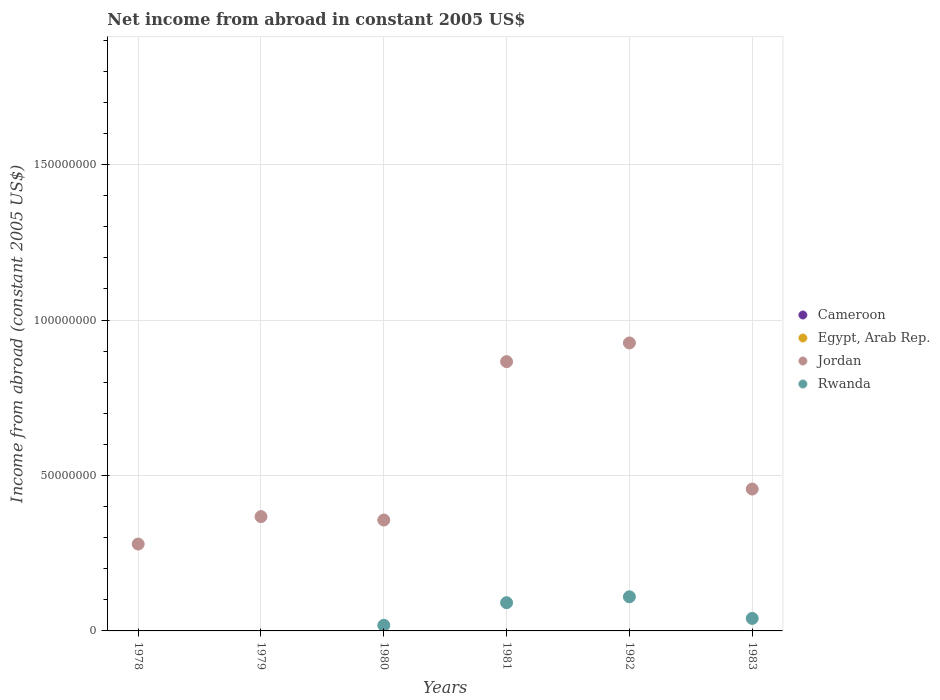How many different coloured dotlines are there?
Your answer should be compact. 2. Is the number of dotlines equal to the number of legend labels?
Your answer should be very brief. No. What is the net income from abroad in Jordan in 1978?
Your response must be concise. 2.79e+07. Across all years, what is the maximum net income from abroad in Rwanda?
Offer a very short reply. 1.10e+07. Across all years, what is the minimum net income from abroad in Cameroon?
Offer a terse response. 0. In which year was the net income from abroad in Rwanda maximum?
Make the answer very short. 1982. What is the total net income from abroad in Rwanda in the graph?
Offer a terse response. 2.59e+07. What is the difference between the net income from abroad in Jordan in 1978 and that in 1980?
Provide a short and direct response. -7.72e+06. What is the difference between the net income from abroad in Rwanda in 1979 and the net income from abroad in Jordan in 1981?
Ensure brevity in your answer.  -8.66e+07. In the year 1980, what is the difference between the net income from abroad in Jordan and net income from abroad in Rwanda?
Give a very brief answer. 3.39e+07. In how many years, is the net income from abroad in Cameroon greater than 160000000 US$?
Your response must be concise. 0. What is the ratio of the net income from abroad in Rwanda in 1980 to that in 1981?
Your answer should be compact. 0.2. What is the difference between the highest and the second highest net income from abroad in Rwanda?
Provide a succinct answer. 1.90e+06. What is the difference between the highest and the lowest net income from abroad in Rwanda?
Keep it short and to the point. 1.10e+07. Is the sum of the net income from abroad in Jordan in 1980 and 1982 greater than the maximum net income from abroad in Egypt, Arab Rep. across all years?
Your response must be concise. Yes. Is it the case that in every year, the sum of the net income from abroad in Rwanda and net income from abroad in Egypt, Arab Rep.  is greater than the net income from abroad in Jordan?
Offer a terse response. No. How many dotlines are there?
Keep it short and to the point. 2. How many years are there in the graph?
Offer a terse response. 6. What is the difference between two consecutive major ticks on the Y-axis?
Keep it short and to the point. 5.00e+07. Are the values on the major ticks of Y-axis written in scientific E-notation?
Give a very brief answer. No. Does the graph contain any zero values?
Make the answer very short. Yes. How many legend labels are there?
Offer a terse response. 4. How are the legend labels stacked?
Make the answer very short. Vertical. What is the title of the graph?
Make the answer very short. Net income from abroad in constant 2005 US$. What is the label or title of the X-axis?
Your response must be concise. Years. What is the label or title of the Y-axis?
Provide a short and direct response. Income from abroad (constant 2005 US$). What is the Income from abroad (constant 2005 US$) in Cameroon in 1978?
Provide a short and direct response. 0. What is the Income from abroad (constant 2005 US$) of Jordan in 1978?
Keep it short and to the point. 2.79e+07. What is the Income from abroad (constant 2005 US$) in Cameroon in 1979?
Keep it short and to the point. 0. What is the Income from abroad (constant 2005 US$) in Egypt, Arab Rep. in 1979?
Ensure brevity in your answer.  0. What is the Income from abroad (constant 2005 US$) in Jordan in 1979?
Give a very brief answer. 3.68e+07. What is the Income from abroad (constant 2005 US$) in Rwanda in 1979?
Provide a succinct answer. 0. What is the Income from abroad (constant 2005 US$) of Jordan in 1980?
Keep it short and to the point. 3.57e+07. What is the Income from abroad (constant 2005 US$) of Rwanda in 1980?
Provide a short and direct response. 1.80e+06. What is the Income from abroad (constant 2005 US$) in Jordan in 1981?
Offer a very short reply. 8.66e+07. What is the Income from abroad (constant 2005 US$) in Rwanda in 1981?
Make the answer very short. 9.08e+06. What is the Income from abroad (constant 2005 US$) of Egypt, Arab Rep. in 1982?
Provide a succinct answer. 0. What is the Income from abroad (constant 2005 US$) of Jordan in 1982?
Offer a terse response. 9.26e+07. What is the Income from abroad (constant 2005 US$) of Rwanda in 1982?
Offer a very short reply. 1.10e+07. What is the Income from abroad (constant 2005 US$) in Egypt, Arab Rep. in 1983?
Offer a very short reply. 0. What is the Income from abroad (constant 2005 US$) of Jordan in 1983?
Your answer should be compact. 4.56e+07. What is the Income from abroad (constant 2005 US$) in Rwanda in 1983?
Your answer should be very brief. 4.03e+06. Across all years, what is the maximum Income from abroad (constant 2005 US$) in Jordan?
Your answer should be very brief. 9.26e+07. Across all years, what is the maximum Income from abroad (constant 2005 US$) of Rwanda?
Your answer should be compact. 1.10e+07. Across all years, what is the minimum Income from abroad (constant 2005 US$) of Jordan?
Keep it short and to the point. 2.79e+07. What is the total Income from abroad (constant 2005 US$) of Egypt, Arab Rep. in the graph?
Keep it short and to the point. 0. What is the total Income from abroad (constant 2005 US$) in Jordan in the graph?
Your answer should be very brief. 3.25e+08. What is the total Income from abroad (constant 2005 US$) of Rwanda in the graph?
Your answer should be compact. 2.59e+07. What is the difference between the Income from abroad (constant 2005 US$) of Jordan in 1978 and that in 1979?
Give a very brief answer. -8.82e+06. What is the difference between the Income from abroad (constant 2005 US$) of Jordan in 1978 and that in 1980?
Keep it short and to the point. -7.72e+06. What is the difference between the Income from abroad (constant 2005 US$) in Jordan in 1978 and that in 1981?
Offer a very short reply. -5.87e+07. What is the difference between the Income from abroad (constant 2005 US$) in Jordan in 1978 and that in 1982?
Provide a succinct answer. -6.47e+07. What is the difference between the Income from abroad (constant 2005 US$) of Jordan in 1978 and that in 1983?
Provide a succinct answer. -1.77e+07. What is the difference between the Income from abroad (constant 2005 US$) of Jordan in 1979 and that in 1980?
Your answer should be compact. 1.10e+06. What is the difference between the Income from abroad (constant 2005 US$) in Jordan in 1979 and that in 1981?
Provide a succinct answer. -4.98e+07. What is the difference between the Income from abroad (constant 2005 US$) in Jordan in 1979 and that in 1982?
Your response must be concise. -5.59e+07. What is the difference between the Income from abroad (constant 2005 US$) in Jordan in 1979 and that in 1983?
Ensure brevity in your answer.  -8.87e+06. What is the difference between the Income from abroad (constant 2005 US$) of Jordan in 1980 and that in 1981?
Ensure brevity in your answer.  -5.09e+07. What is the difference between the Income from abroad (constant 2005 US$) in Rwanda in 1980 and that in 1981?
Ensure brevity in your answer.  -7.27e+06. What is the difference between the Income from abroad (constant 2005 US$) of Jordan in 1980 and that in 1982?
Your answer should be very brief. -5.70e+07. What is the difference between the Income from abroad (constant 2005 US$) of Rwanda in 1980 and that in 1982?
Your response must be concise. -9.17e+06. What is the difference between the Income from abroad (constant 2005 US$) in Jordan in 1980 and that in 1983?
Provide a short and direct response. -9.97e+06. What is the difference between the Income from abroad (constant 2005 US$) in Rwanda in 1980 and that in 1983?
Provide a succinct answer. -2.22e+06. What is the difference between the Income from abroad (constant 2005 US$) in Jordan in 1981 and that in 1982?
Offer a terse response. -6.02e+06. What is the difference between the Income from abroad (constant 2005 US$) in Rwanda in 1981 and that in 1982?
Ensure brevity in your answer.  -1.90e+06. What is the difference between the Income from abroad (constant 2005 US$) of Jordan in 1981 and that in 1983?
Your answer should be compact. 4.10e+07. What is the difference between the Income from abroad (constant 2005 US$) in Rwanda in 1981 and that in 1983?
Give a very brief answer. 5.05e+06. What is the difference between the Income from abroad (constant 2005 US$) of Jordan in 1982 and that in 1983?
Offer a terse response. 4.70e+07. What is the difference between the Income from abroad (constant 2005 US$) in Rwanda in 1982 and that in 1983?
Your answer should be very brief. 6.95e+06. What is the difference between the Income from abroad (constant 2005 US$) of Jordan in 1978 and the Income from abroad (constant 2005 US$) of Rwanda in 1980?
Your answer should be very brief. 2.61e+07. What is the difference between the Income from abroad (constant 2005 US$) in Jordan in 1978 and the Income from abroad (constant 2005 US$) in Rwanda in 1981?
Your answer should be very brief. 1.89e+07. What is the difference between the Income from abroad (constant 2005 US$) of Jordan in 1978 and the Income from abroad (constant 2005 US$) of Rwanda in 1982?
Offer a very short reply. 1.70e+07. What is the difference between the Income from abroad (constant 2005 US$) in Jordan in 1978 and the Income from abroad (constant 2005 US$) in Rwanda in 1983?
Provide a succinct answer. 2.39e+07. What is the difference between the Income from abroad (constant 2005 US$) in Jordan in 1979 and the Income from abroad (constant 2005 US$) in Rwanda in 1980?
Keep it short and to the point. 3.50e+07. What is the difference between the Income from abroad (constant 2005 US$) in Jordan in 1979 and the Income from abroad (constant 2005 US$) in Rwanda in 1981?
Provide a short and direct response. 2.77e+07. What is the difference between the Income from abroad (constant 2005 US$) in Jordan in 1979 and the Income from abroad (constant 2005 US$) in Rwanda in 1982?
Offer a terse response. 2.58e+07. What is the difference between the Income from abroad (constant 2005 US$) in Jordan in 1979 and the Income from abroad (constant 2005 US$) in Rwanda in 1983?
Make the answer very short. 3.27e+07. What is the difference between the Income from abroad (constant 2005 US$) in Jordan in 1980 and the Income from abroad (constant 2005 US$) in Rwanda in 1981?
Give a very brief answer. 2.66e+07. What is the difference between the Income from abroad (constant 2005 US$) of Jordan in 1980 and the Income from abroad (constant 2005 US$) of Rwanda in 1982?
Give a very brief answer. 2.47e+07. What is the difference between the Income from abroad (constant 2005 US$) of Jordan in 1980 and the Income from abroad (constant 2005 US$) of Rwanda in 1983?
Ensure brevity in your answer.  3.16e+07. What is the difference between the Income from abroad (constant 2005 US$) of Jordan in 1981 and the Income from abroad (constant 2005 US$) of Rwanda in 1982?
Ensure brevity in your answer.  7.56e+07. What is the difference between the Income from abroad (constant 2005 US$) of Jordan in 1981 and the Income from abroad (constant 2005 US$) of Rwanda in 1983?
Provide a succinct answer. 8.26e+07. What is the difference between the Income from abroad (constant 2005 US$) of Jordan in 1982 and the Income from abroad (constant 2005 US$) of Rwanda in 1983?
Give a very brief answer. 8.86e+07. What is the average Income from abroad (constant 2005 US$) of Cameroon per year?
Provide a succinct answer. 0. What is the average Income from abroad (constant 2005 US$) in Jordan per year?
Give a very brief answer. 5.42e+07. What is the average Income from abroad (constant 2005 US$) of Rwanda per year?
Your answer should be very brief. 4.31e+06. In the year 1980, what is the difference between the Income from abroad (constant 2005 US$) of Jordan and Income from abroad (constant 2005 US$) of Rwanda?
Provide a short and direct response. 3.39e+07. In the year 1981, what is the difference between the Income from abroad (constant 2005 US$) in Jordan and Income from abroad (constant 2005 US$) in Rwanda?
Provide a succinct answer. 7.75e+07. In the year 1982, what is the difference between the Income from abroad (constant 2005 US$) of Jordan and Income from abroad (constant 2005 US$) of Rwanda?
Provide a succinct answer. 8.17e+07. In the year 1983, what is the difference between the Income from abroad (constant 2005 US$) in Jordan and Income from abroad (constant 2005 US$) in Rwanda?
Keep it short and to the point. 4.16e+07. What is the ratio of the Income from abroad (constant 2005 US$) in Jordan in 1978 to that in 1979?
Provide a succinct answer. 0.76. What is the ratio of the Income from abroad (constant 2005 US$) of Jordan in 1978 to that in 1980?
Your response must be concise. 0.78. What is the ratio of the Income from abroad (constant 2005 US$) in Jordan in 1978 to that in 1981?
Offer a terse response. 0.32. What is the ratio of the Income from abroad (constant 2005 US$) of Jordan in 1978 to that in 1982?
Your answer should be very brief. 0.3. What is the ratio of the Income from abroad (constant 2005 US$) of Jordan in 1978 to that in 1983?
Your response must be concise. 0.61. What is the ratio of the Income from abroad (constant 2005 US$) in Jordan in 1979 to that in 1980?
Offer a very short reply. 1.03. What is the ratio of the Income from abroad (constant 2005 US$) in Jordan in 1979 to that in 1981?
Offer a very short reply. 0.42. What is the ratio of the Income from abroad (constant 2005 US$) in Jordan in 1979 to that in 1982?
Offer a very short reply. 0.4. What is the ratio of the Income from abroad (constant 2005 US$) of Jordan in 1979 to that in 1983?
Ensure brevity in your answer.  0.81. What is the ratio of the Income from abroad (constant 2005 US$) of Jordan in 1980 to that in 1981?
Keep it short and to the point. 0.41. What is the ratio of the Income from abroad (constant 2005 US$) of Rwanda in 1980 to that in 1981?
Provide a succinct answer. 0.2. What is the ratio of the Income from abroad (constant 2005 US$) in Jordan in 1980 to that in 1982?
Give a very brief answer. 0.39. What is the ratio of the Income from abroad (constant 2005 US$) in Rwanda in 1980 to that in 1982?
Keep it short and to the point. 0.16. What is the ratio of the Income from abroad (constant 2005 US$) of Jordan in 1980 to that in 1983?
Your answer should be compact. 0.78. What is the ratio of the Income from abroad (constant 2005 US$) of Rwanda in 1980 to that in 1983?
Keep it short and to the point. 0.45. What is the ratio of the Income from abroad (constant 2005 US$) in Jordan in 1981 to that in 1982?
Provide a succinct answer. 0.94. What is the ratio of the Income from abroad (constant 2005 US$) in Rwanda in 1981 to that in 1982?
Offer a very short reply. 0.83. What is the ratio of the Income from abroad (constant 2005 US$) in Jordan in 1981 to that in 1983?
Make the answer very short. 1.9. What is the ratio of the Income from abroad (constant 2005 US$) of Rwanda in 1981 to that in 1983?
Ensure brevity in your answer.  2.25. What is the ratio of the Income from abroad (constant 2005 US$) of Jordan in 1982 to that in 1983?
Give a very brief answer. 2.03. What is the ratio of the Income from abroad (constant 2005 US$) in Rwanda in 1982 to that in 1983?
Offer a very short reply. 2.73. What is the difference between the highest and the second highest Income from abroad (constant 2005 US$) of Jordan?
Make the answer very short. 6.02e+06. What is the difference between the highest and the second highest Income from abroad (constant 2005 US$) of Rwanda?
Your answer should be compact. 1.90e+06. What is the difference between the highest and the lowest Income from abroad (constant 2005 US$) of Jordan?
Keep it short and to the point. 6.47e+07. What is the difference between the highest and the lowest Income from abroad (constant 2005 US$) of Rwanda?
Provide a succinct answer. 1.10e+07. 